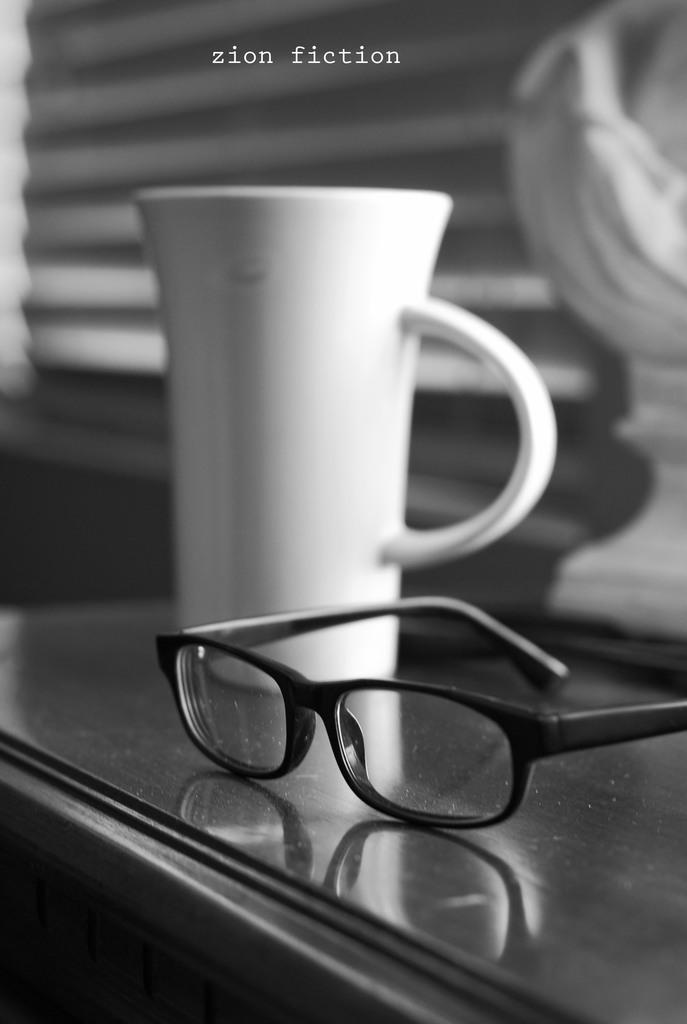What piece of furniture is present in the image? There is a table in the image. What is placed on the table? There is a white-colored cup and black-colored spectacles on the table. Can you describe the appearance of the cup? The cup is white in color. What is the condition of the objects in the background of the image? The objects in the background are blurry. What type of animal is sitting on the table in the image? There is no animal present on the table in the image. Can you describe the design of the zipper on the cup? There is no zipper on the cup in the image; it is a simple white-colored cup. 